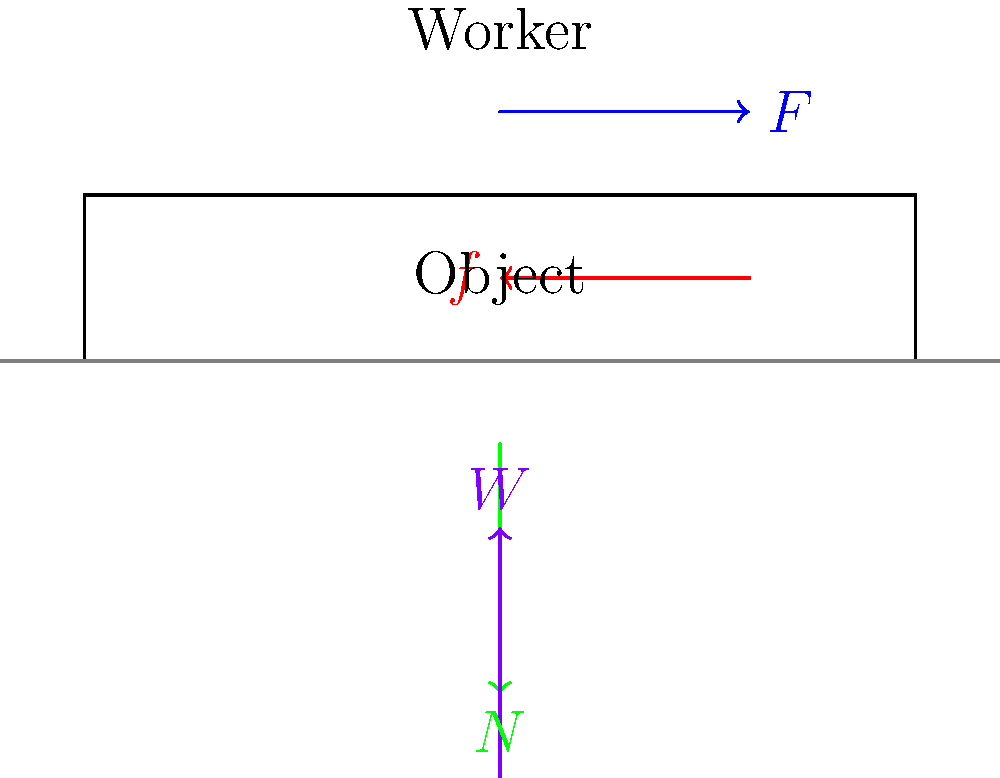In the force diagram above, a worker is pushing a heavy object on a flat surface. The applied force $F$ is horizontal, and the object experiences friction $f$. What is the relationship between the normal force $N$ and the weight of the object $W$ in this scenario? To understand the relationship between the normal force $N$ and the weight $W$, let's analyze the forces acting on the object:

1. The weight $W$ acts downward due to gravity.
2. The normal force $N$ acts upward, perpendicular to the surface.
3. The applied force $F$ acts horizontally, parallel to the surface.
4. The friction force $f$ acts horizontally, opposite to the direction of motion.

In this scenario, the object is on a flat surface and not accelerating vertically. Therefore, the vertical forces must be balanced according to Newton's Second Law:

$$\sum F_y = 0$$

The only vertical forces acting on the object are the normal force $N$ (upward) and the weight $W$ (downward). Thus:

$$N - W = 0$$

Rearranging this equation, we get:

$$N = W$$

This relationship holds true because the surface is flat and horizontal. If the surface were inclined, the relationship would be different.
Answer: $N = W$ 